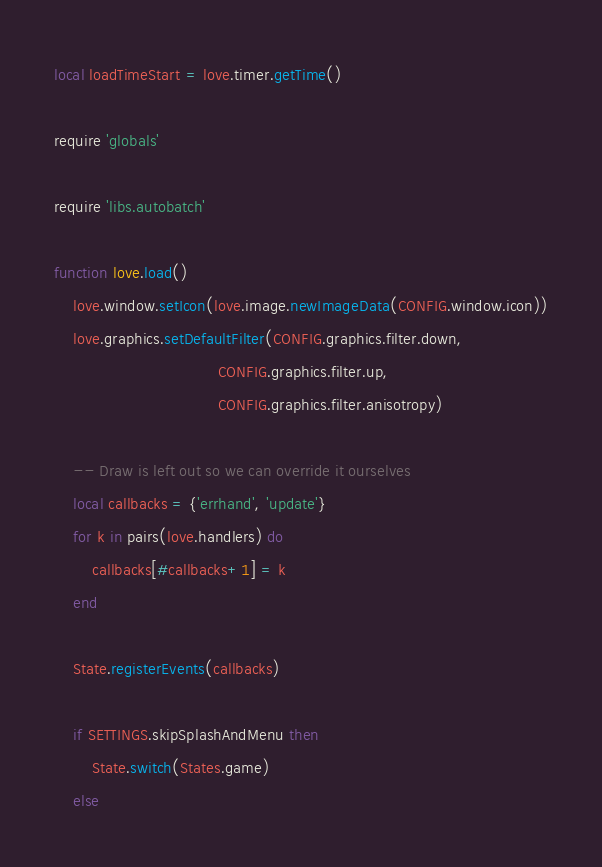Convert code to text. <code><loc_0><loc_0><loc_500><loc_500><_Lua_>local loadTimeStart = love.timer.getTime()

require 'globals'

require 'libs.autobatch'

function love.load()
    love.window.setIcon(love.image.newImageData(CONFIG.window.icon))
    love.graphics.setDefaultFilter(CONFIG.graphics.filter.down,
                                   CONFIG.graphics.filter.up,
                                   CONFIG.graphics.filter.anisotropy)

    -- Draw is left out so we can override it ourselves
    local callbacks = {'errhand', 'update'}
    for k in pairs(love.handlers) do
        callbacks[#callbacks+1] = k
    end

    State.registerEvents(callbacks)

    if SETTINGS.skipSplashAndMenu then
        State.switch(States.game)
    else</code> 